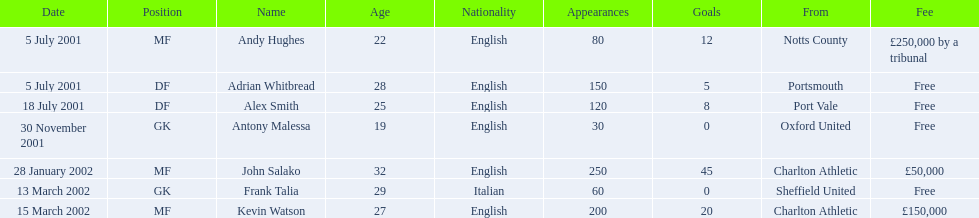Which players in the 2001-02 reading f.c. season played the mf position? Andy Hughes, John Salako, Kevin Watson. Of these players, which ones transferred in 2002? John Salako, Kevin Watson. Of these players, who had the highest transfer fee? Kevin Watson. What was this player's transfer fee? £150,000. 